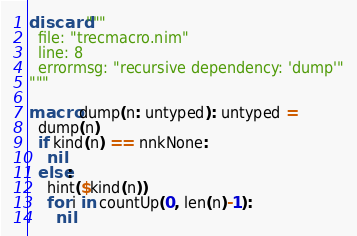Convert code to text. <code><loc_0><loc_0><loc_500><loc_500><_Nim_>discard """
  file: "trecmacro.nim"
  line: 8
  errormsg: "recursive dependency: 'dump'"
"""

macro dump(n: untyped): untyped =
  dump(n)
  if kind(n) == nnkNone:
    nil
  else:
    hint($kind(n))
    for i in countUp(0, len(n)-1):
      nil
</code> 